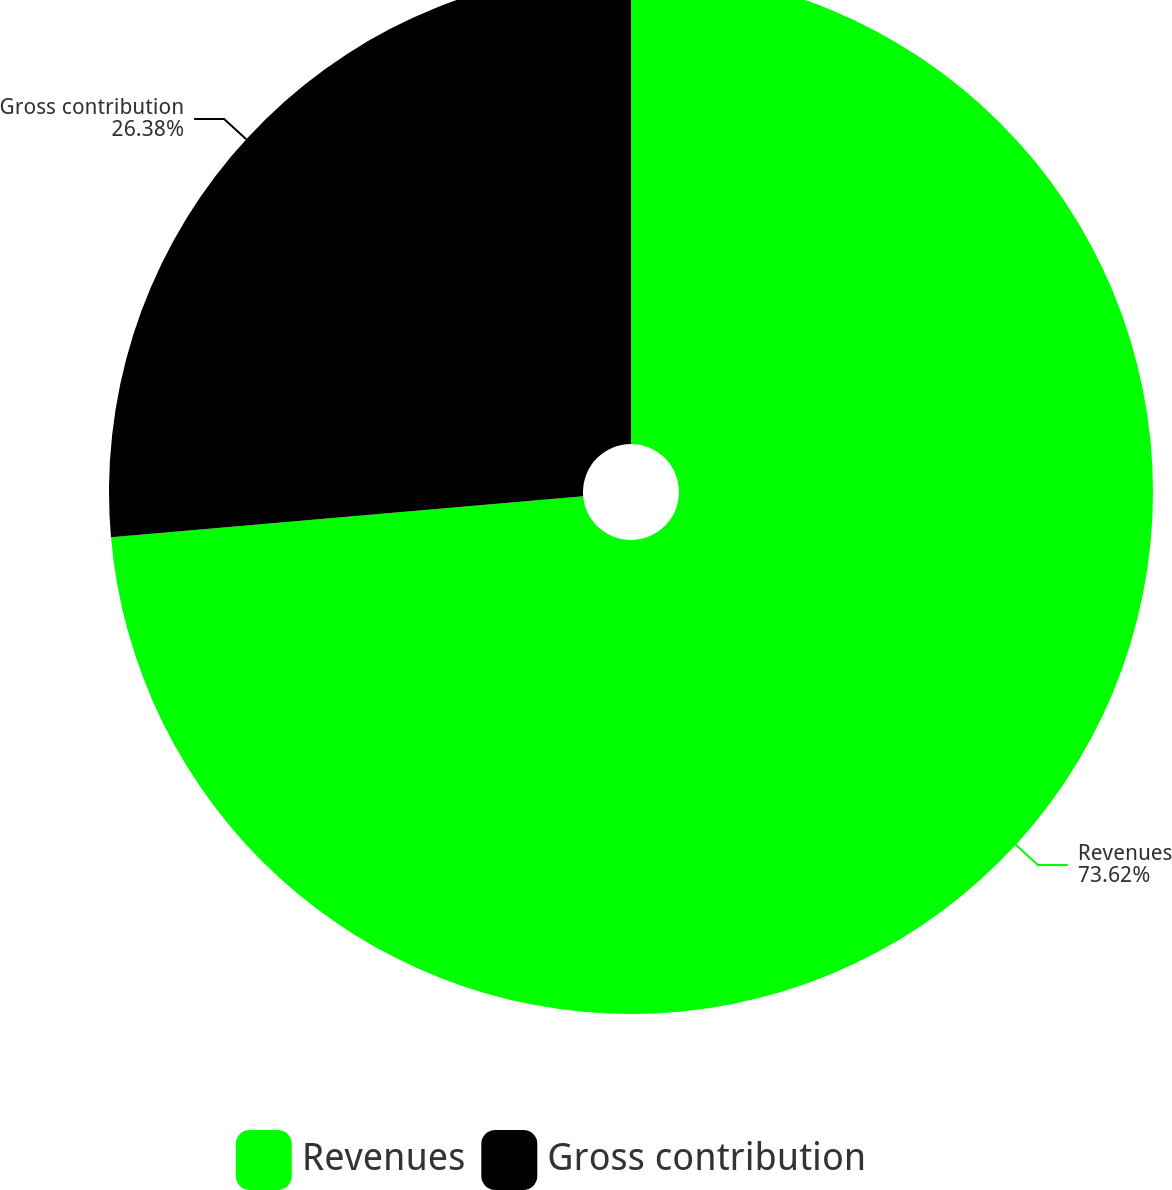Convert chart to OTSL. <chart><loc_0><loc_0><loc_500><loc_500><pie_chart><fcel>Revenues<fcel>Gross contribution<nl><fcel>73.62%<fcel>26.38%<nl></chart> 